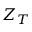Convert formula to latex. <formula><loc_0><loc_0><loc_500><loc_500>Z _ { T }</formula> 